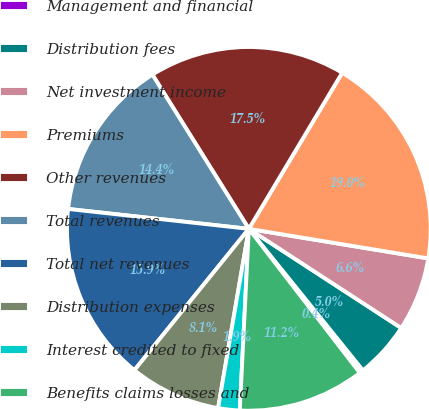Convert chart to OTSL. <chart><loc_0><loc_0><loc_500><loc_500><pie_chart><fcel>Management and financial<fcel>Distribution fees<fcel>Net investment income<fcel>Premiums<fcel>Other revenues<fcel>Total revenues<fcel>Total net revenues<fcel>Distribution expenses<fcel>Interest credited to fixed<fcel>Benefits claims losses and<nl><fcel>0.35%<fcel>5.02%<fcel>6.58%<fcel>19.02%<fcel>17.47%<fcel>14.36%<fcel>15.91%<fcel>8.13%<fcel>1.91%<fcel>11.24%<nl></chart> 